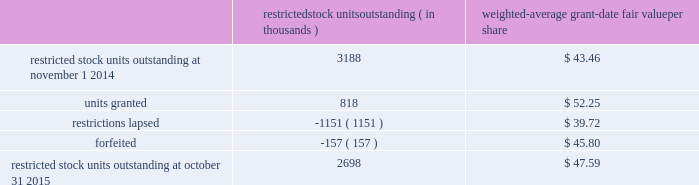Analog devices , inc .
Notes to consolidated financial statements 2014 ( continued ) a summary of the company 2019s restricted stock unit award activity as of october 31 , 2015 and changes during the fiscal year then ended is presented below : restricted stock units outstanding ( in thousands ) weighted- average grant- date fair value per share .
As of october 31 , 2015 , there was $ 108.8 million of total unrecognized compensation cost related to unvested share- based awards comprised of stock options and restricted stock units .
That cost is expected to be recognized over a weighted- average period of 1.3 years .
The total grant-date fair value of shares that vested during fiscal 2015 , 2014 and 2013 was approximately $ 65.6 million , $ 57.4 million and $ 63.9 million , respectively .
Common stock repurchase program the company 2019s common stock repurchase program has been in place since august 2004 .
In the aggregate , the board of directors have authorized the company to repurchase $ 5.6 billion of the company 2019s common stock under the program .
Under the program , the company may repurchase outstanding shares of its common stock from time to time in the open market and through privately negotiated transactions .
Unless terminated earlier by resolution of the company 2019s board of directors , the repurchase program will expire when the company has repurchased all shares authorized under the program .
As of october 31 , 2015 , the company had repurchased a total of approximately 140.7 million shares of its common stock for approximately $ 5.0 billion under this program .
An additional $ 544.5 million remains available for repurchase of shares under the current authorized program .
The repurchased shares are held as authorized but unissued shares of common stock .
The company also , from time to time , repurchases shares in settlement of employee minimum tax withholding obligations due upon the vesting of restricted stock units or the exercise of stock options .
The withholding amount is based on the employees minimum statutory withholding requirement .
Any future common stock repurchases will be dependent upon several factors , including the company's financial performance , outlook , liquidity and the amount of cash the company has available in the united states .
Preferred stock the company has 471934 authorized shares of $ 1.00 par value preferred stock , none of which is issued or outstanding .
The board of directors is authorized to fix designations , relative rights , preferences and limitations on the preferred stock at the time of issuance .
Industry , segment and geographic information the company operates and tracks its results in one reportable segment based on the aggregation of six operating segments .
The company designs , develops , manufactures and markets a broad range of integrated circuits ( ics ) .
The chief executive officer has been identified as the company's chief operating decision maker .
The company has determined that all of the company's operating segments share the following similar economic characteristics , and therefore meet the criteria established for operating segments to be aggregated into one reportable segment , namely : 2022 the primary source of revenue for each operating segment is the sale of integrated circuits .
2022 the integrated circuits sold by each of the company's operating segments are manufactured using similar semiconductor manufacturing processes and raw materials in either the company 2019s own production facilities or by third-party wafer fabricators using proprietary processes .
2022 the company sells its products to tens of thousands of customers worldwide .
Many of these customers use products spanning all operating segments in a wide range of applications .
2022 the integrated circuits marketed by each of the company's operating segments are sold globally through a direct sales force , third-party distributors , independent sales representatives and via our website to the same types of customers .
All of the company's operating segments share a similar long-term financial model as they have similar economic characteristics .
The causes for variation in operating and financial performance are the same among the company's operating segments and include factors such as ( i ) life cycle and price and cost fluctuations , ( ii ) number of competitors , ( iii ) product .
What is the total fair value of the total restricted stock units outstanding at october 31 , 2015? 
Computations: (2698 / 47.59)
Answer: 56.69258. 